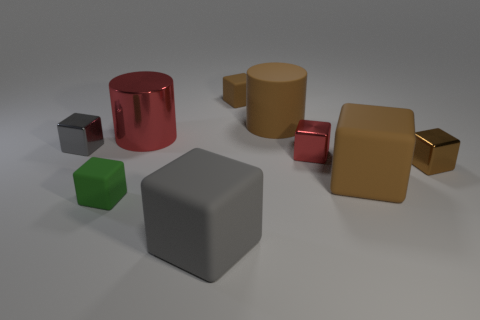Can you describe the shapes and colors of the objects in the image? Certainly! In the image, we have multiple geometric shapes: two cubes, one large metallic gray and one small dark gray; a cylinder that's glossy red; a bronze block; and two parallelepipeds, one being matte light brown and the other shiny gold. The background is neutral, providing soft lighting. 